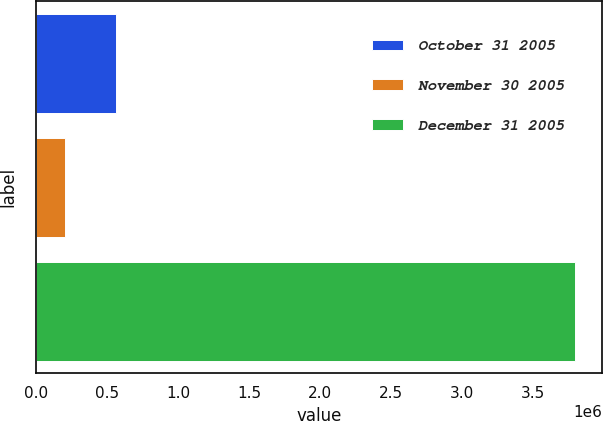Convert chart. <chart><loc_0><loc_0><loc_500><loc_500><bar_chart><fcel>October 31 2005<fcel>November 30 2005<fcel>December 31 2005<nl><fcel>560000<fcel>200000<fcel>3.8e+06<nl></chart> 